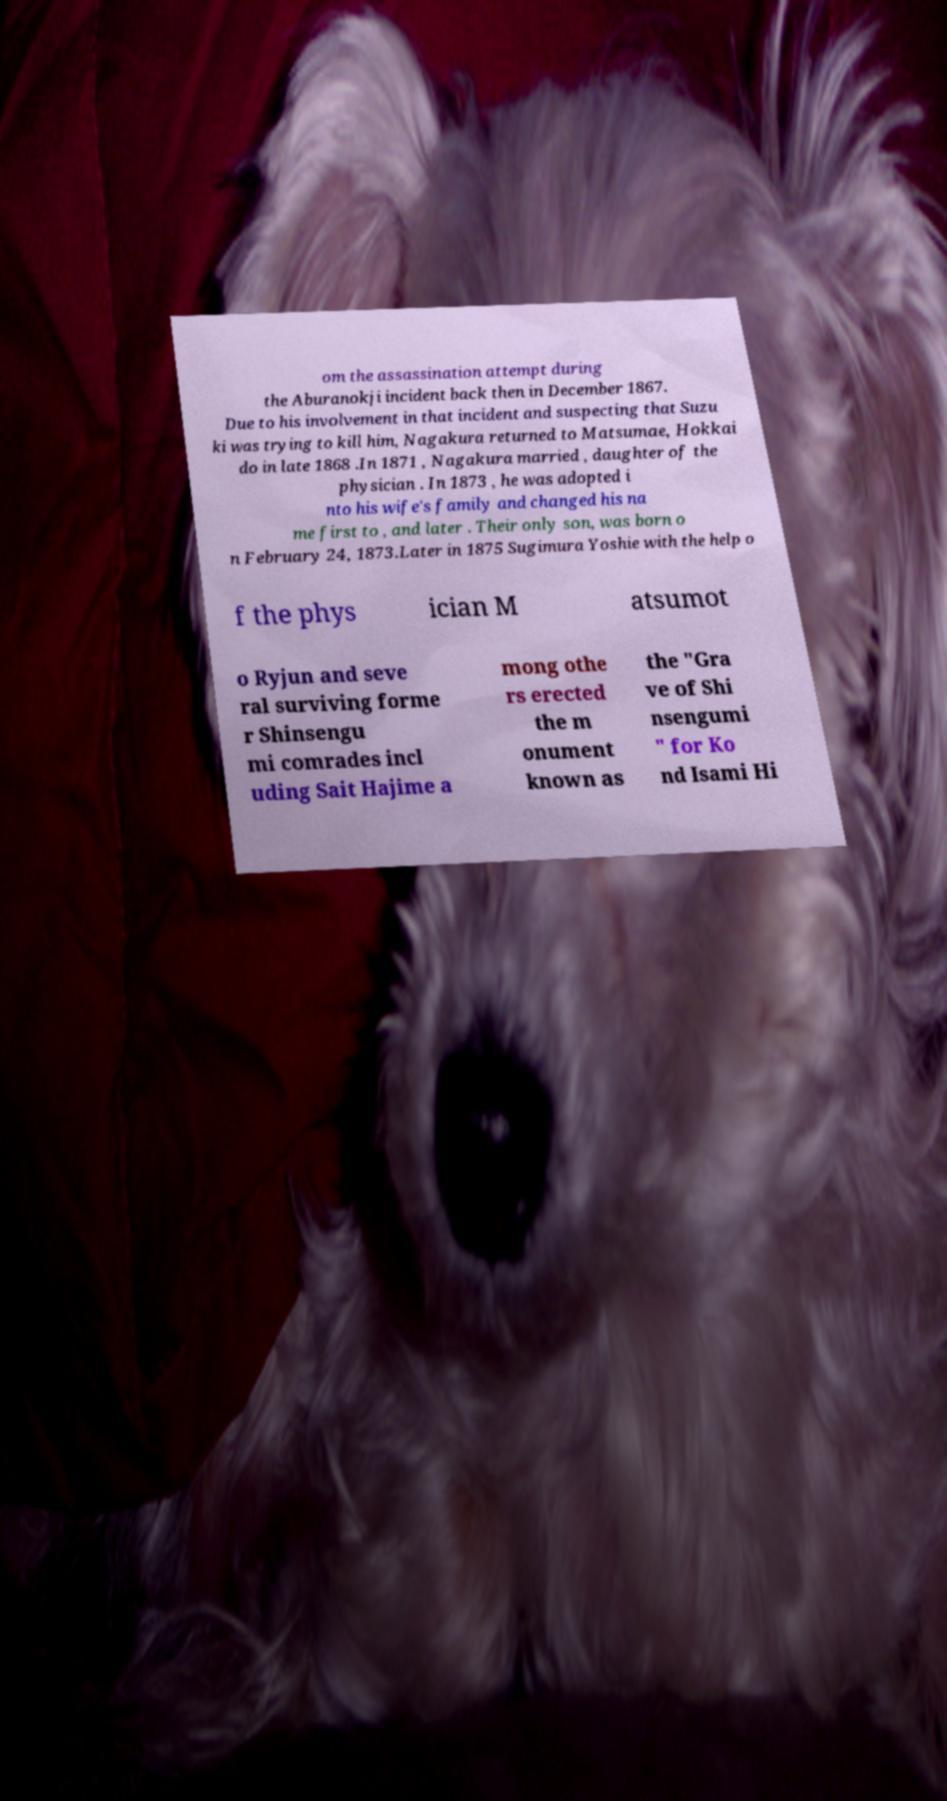I need the written content from this picture converted into text. Can you do that? om the assassination attempt during the Aburanokji incident back then in December 1867. Due to his involvement in that incident and suspecting that Suzu ki was trying to kill him, Nagakura returned to Matsumae, Hokkai do in late 1868 .In 1871 , Nagakura married , daughter of the physician . In 1873 , he was adopted i nto his wife's family and changed his na me first to , and later . Their only son, was born o n February 24, 1873.Later in 1875 Sugimura Yoshie with the help o f the phys ician M atsumot o Ryjun and seve ral surviving forme r Shinsengu mi comrades incl uding Sait Hajime a mong othe rs erected the m onument known as the "Gra ve of Shi nsengumi " for Ko nd Isami Hi 